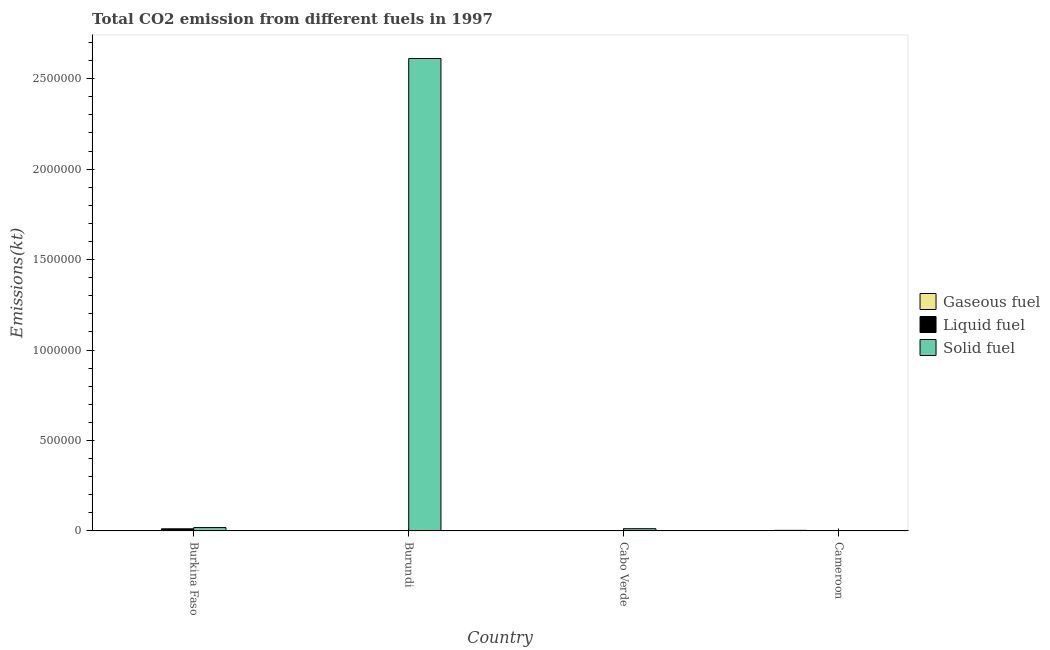How many different coloured bars are there?
Keep it short and to the point. 3. How many groups of bars are there?
Make the answer very short. 4. Are the number of bars per tick equal to the number of legend labels?
Give a very brief answer. Yes. How many bars are there on the 1st tick from the left?
Your response must be concise. 3. What is the label of the 1st group of bars from the left?
Ensure brevity in your answer.  Burkina Faso. What is the amount of co2 emissions from gaseous fuel in Burkina Faso?
Your answer should be compact. 806.74. Across all countries, what is the maximum amount of co2 emissions from liquid fuel?
Offer a very short reply. 1.17e+04. Across all countries, what is the minimum amount of co2 emissions from solid fuel?
Give a very brief answer. 861.75. In which country was the amount of co2 emissions from gaseous fuel maximum?
Offer a very short reply. Cameroon. In which country was the amount of co2 emissions from gaseous fuel minimum?
Give a very brief answer. Cabo Verde. What is the total amount of co2 emissions from liquid fuel in the graph?
Your answer should be very brief. 1.43e+04. What is the difference between the amount of co2 emissions from liquid fuel in Burkina Faso and that in Cabo Verde?
Ensure brevity in your answer.  1.14e+04. What is the difference between the amount of co2 emissions from gaseous fuel in Burundi and the amount of co2 emissions from liquid fuel in Cameroon?
Provide a succinct answer. -1162.44. What is the average amount of co2 emissions from solid fuel per country?
Ensure brevity in your answer.  6.61e+05. What is the difference between the amount of co2 emissions from gaseous fuel and amount of co2 emissions from solid fuel in Cameroon?
Make the answer very short. 2354.21. In how many countries, is the amount of co2 emissions from solid fuel greater than 1300000 kt?
Provide a short and direct response. 1. What is the ratio of the amount of co2 emissions from liquid fuel in Cabo Verde to that in Cameroon?
Provide a short and direct response. 0.2. Is the amount of co2 emissions from solid fuel in Burkina Faso less than that in Cameroon?
Your response must be concise. No. Is the difference between the amount of co2 emissions from liquid fuel in Cabo Verde and Cameroon greater than the difference between the amount of co2 emissions from solid fuel in Cabo Verde and Cameroon?
Offer a terse response. No. What is the difference between the highest and the second highest amount of co2 emissions from liquid fuel?
Your answer should be very brief. 1.03e+04. What is the difference between the highest and the lowest amount of co2 emissions from liquid fuel?
Your response must be concise. 1.14e+04. What does the 3rd bar from the left in Burundi represents?
Provide a succinct answer. Solid fuel. What does the 3rd bar from the right in Burundi represents?
Provide a succinct answer. Gaseous fuel. Is it the case that in every country, the sum of the amount of co2 emissions from gaseous fuel and amount of co2 emissions from liquid fuel is greater than the amount of co2 emissions from solid fuel?
Keep it short and to the point. No. Are all the bars in the graph horizontal?
Offer a terse response. No. How many countries are there in the graph?
Offer a terse response. 4. What is the difference between two consecutive major ticks on the Y-axis?
Keep it short and to the point. 5.00e+05. Does the graph contain grids?
Give a very brief answer. No. Where does the legend appear in the graph?
Give a very brief answer. Center right. How are the legend labels stacked?
Give a very brief answer. Vertical. What is the title of the graph?
Make the answer very short. Total CO2 emission from different fuels in 1997. What is the label or title of the X-axis?
Provide a succinct answer. Country. What is the label or title of the Y-axis?
Offer a very short reply. Emissions(kt). What is the Emissions(kt) in Gaseous fuel in Burkina Faso?
Your answer should be very brief. 806.74. What is the Emissions(kt) in Liquid fuel in Burkina Faso?
Your response must be concise. 1.17e+04. What is the Emissions(kt) of Solid fuel in Burkina Faso?
Offer a terse response. 1.86e+04. What is the Emissions(kt) of Gaseous fuel in Burundi?
Your answer should be compact. 304.36. What is the Emissions(kt) in Liquid fuel in Burundi?
Offer a very short reply. 788.4. What is the Emissions(kt) of Solid fuel in Burundi?
Give a very brief answer. 2.61e+06. What is the Emissions(kt) in Gaseous fuel in Cabo Verde?
Give a very brief answer. 143.01. What is the Emissions(kt) in Liquid fuel in Cabo Verde?
Give a very brief answer. 289.69. What is the Emissions(kt) in Solid fuel in Cabo Verde?
Your answer should be very brief. 1.23e+04. What is the Emissions(kt) in Gaseous fuel in Cameroon?
Provide a succinct answer. 3215.96. What is the Emissions(kt) of Liquid fuel in Cameroon?
Your answer should be compact. 1466.8. What is the Emissions(kt) in Solid fuel in Cameroon?
Provide a short and direct response. 861.75. Across all countries, what is the maximum Emissions(kt) in Gaseous fuel?
Provide a short and direct response. 3215.96. Across all countries, what is the maximum Emissions(kt) of Liquid fuel?
Give a very brief answer. 1.17e+04. Across all countries, what is the maximum Emissions(kt) in Solid fuel?
Offer a very short reply. 2.61e+06. Across all countries, what is the minimum Emissions(kt) in Gaseous fuel?
Your answer should be very brief. 143.01. Across all countries, what is the minimum Emissions(kt) of Liquid fuel?
Your answer should be compact. 289.69. Across all countries, what is the minimum Emissions(kt) of Solid fuel?
Provide a short and direct response. 861.75. What is the total Emissions(kt) of Gaseous fuel in the graph?
Offer a very short reply. 4470.07. What is the total Emissions(kt) in Liquid fuel in the graph?
Your answer should be compact. 1.43e+04. What is the total Emissions(kt) in Solid fuel in the graph?
Provide a succinct answer. 2.64e+06. What is the difference between the Emissions(kt) in Gaseous fuel in Burkina Faso and that in Burundi?
Keep it short and to the point. 502.38. What is the difference between the Emissions(kt) of Liquid fuel in Burkina Faso and that in Burundi?
Offer a very short reply. 1.09e+04. What is the difference between the Emissions(kt) in Solid fuel in Burkina Faso and that in Burundi?
Give a very brief answer. -2.59e+06. What is the difference between the Emissions(kt) of Gaseous fuel in Burkina Faso and that in Cabo Verde?
Provide a succinct answer. 663.73. What is the difference between the Emissions(kt) in Liquid fuel in Burkina Faso and that in Cabo Verde?
Keep it short and to the point. 1.14e+04. What is the difference between the Emissions(kt) in Solid fuel in Burkina Faso and that in Cabo Verde?
Offer a very short reply. 6321.91. What is the difference between the Emissions(kt) of Gaseous fuel in Burkina Faso and that in Cameroon?
Your answer should be very brief. -2409.22. What is the difference between the Emissions(kt) of Liquid fuel in Burkina Faso and that in Cameroon?
Your answer should be compact. 1.03e+04. What is the difference between the Emissions(kt) in Solid fuel in Burkina Faso and that in Cameroon?
Offer a very short reply. 1.78e+04. What is the difference between the Emissions(kt) in Gaseous fuel in Burundi and that in Cabo Verde?
Your answer should be very brief. 161.35. What is the difference between the Emissions(kt) of Liquid fuel in Burundi and that in Cabo Verde?
Make the answer very short. 498.71. What is the difference between the Emissions(kt) of Solid fuel in Burundi and that in Cabo Verde?
Your response must be concise. 2.60e+06. What is the difference between the Emissions(kt) of Gaseous fuel in Burundi and that in Cameroon?
Provide a short and direct response. -2911.6. What is the difference between the Emissions(kt) in Liquid fuel in Burundi and that in Cameroon?
Ensure brevity in your answer.  -678.39. What is the difference between the Emissions(kt) of Solid fuel in Burundi and that in Cameroon?
Keep it short and to the point. 2.61e+06. What is the difference between the Emissions(kt) in Gaseous fuel in Cabo Verde and that in Cameroon?
Provide a succinct answer. -3072.95. What is the difference between the Emissions(kt) in Liquid fuel in Cabo Verde and that in Cameroon?
Your answer should be compact. -1177.11. What is the difference between the Emissions(kt) in Solid fuel in Cabo Verde and that in Cameroon?
Provide a succinct answer. 1.14e+04. What is the difference between the Emissions(kt) of Gaseous fuel in Burkina Faso and the Emissions(kt) of Liquid fuel in Burundi?
Your answer should be compact. 18.34. What is the difference between the Emissions(kt) in Gaseous fuel in Burkina Faso and the Emissions(kt) in Solid fuel in Burundi?
Your response must be concise. -2.61e+06. What is the difference between the Emissions(kt) in Liquid fuel in Burkina Faso and the Emissions(kt) in Solid fuel in Burundi?
Keep it short and to the point. -2.60e+06. What is the difference between the Emissions(kt) in Gaseous fuel in Burkina Faso and the Emissions(kt) in Liquid fuel in Cabo Verde?
Your answer should be compact. 517.05. What is the difference between the Emissions(kt) in Gaseous fuel in Burkina Faso and the Emissions(kt) in Solid fuel in Cabo Verde?
Provide a short and direct response. -1.15e+04. What is the difference between the Emissions(kt) in Liquid fuel in Burkina Faso and the Emissions(kt) in Solid fuel in Cabo Verde?
Offer a terse response. -572.05. What is the difference between the Emissions(kt) in Gaseous fuel in Burkina Faso and the Emissions(kt) in Liquid fuel in Cameroon?
Make the answer very short. -660.06. What is the difference between the Emissions(kt) of Gaseous fuel in Burkina Faso and the Emissions(kt) of Solid fuel in Cameroon?
Keep it short and to the point. -55.01. What is the difference between the Emissions(kt) in Liquid fuel in Burkina Faso and the Emissions(kt) in Solid fuel in Cameroon?
Give a very brief answer. 1.09e+04. What is the difference between the Emissions(kt) in Gaseous fuel in Burundi and the Emissions(kt) in Liquid fuel in Cabo Verde?
Your answer should be very brief. 14.67. What is the difference between the Emissions(kt) of Gaseous fuel in Burundi and the Emissions(kt) of Solid fuel in Cabo Verde?
Ensure brevity in your answer.  -1.20e+04. What is the difference between the Emissions(kt) in Liquid fuel in Burundi and the Emissions(kt) in Solid fuel in Cabo Verde?
Ensure brevity in your answer.  -1.15e+04. What is the difference between the Emissions(kt) of Gaseous fuel in Burundi and the Emissions(kt) of Liquid fuel in Cameroon?
Offer a terse response. -1162.44. What is the difference between the Emissions(kt) in Gaseous fuel in Burundi and the Emissions(kt) in Solid fuel in Cameroon?
Give a very brief answer. -557.38. What is the difference between the Emissions(kt) of Liquid fuel in Burundi and the Emissions(kt) of Solid fuel in Cameroon?
Keep it short and to the point. -73.34. What is the difference between the Emissions(kt) of Gaseous fuel in Cabo Verde and the Emissions(kt) of Liquid fuel in Cameroon?
Provide a succinct answer. -1323.79. What is the difference between the Emissions(kt) in Gaseous fuel in Cabo Verde and the Emissions(kt) in Solid fuel in Cameroon?
Provide a succinct answer. -718.73. What is the difference between the Emissions(kt) in Liquid fuel in Cabo Verde and the Emissions(kt) in Solid fuel in Cameroon?
Your response must be concise. -572.05. What is the average Emissions(kt) of Gaseous fuel per country?
Provide a short and direct response. 1117.52. What is the average Emissions(kt) of Liquid fuel per country?
Your answer should be very brief. 3567.99. What is the average Emissions(kt) in Solid fuel per country?
Your answer should be compact. 6.61e+05. What is the difference between the Emissions(kt) in Gaseous fuel and Emissions(kt) in Liquid fuel in Burkina Faso?
Keep it short and to the point. -1.09e+04. What is the difference between the Emissions(kt) in Gaseous fuel and Emissions(kt) in Solid fuel in Burkina Faso?
Ensure brevity in your answer.  -1.78e+04. What is the difference between the Emissions(kt) in Liquid fuel and Emissions(kt) in Solid fuel in Burkina Faso?
Give a very brief answer. -6893.96. What is the difference between the Emissions(kt) of Gaseous fuel and Emissions(kt) of Liquid fuel in Burundi?
Offer a very short reply. -484.04. What is the difference between the Emissions(kt) in Gaseous fuel and Emissions(kt) in Solid fuel in Burundi?
Your response must be concise. -2.61e+06. What is the difference between the Emissions(kt) in Liquid fuel and Emissions(kt) in Solid fuel in Burundi?
Ensure brevity in your answer.  -2.61e+06. What is the difference between the Emissions(kt) of Gaseous fuel and Emissions(kt) of Liquid fuel in Cabo Verde?
Offer a very short reply. -146.68. What is the difference between the Emissions(kt) in Gaseous fuel and Emissions(kt) in Solid fuel in Cabo Verde?
Keep it short and to the point. -1.22e+04. What is the difference between the Emissions(kt) in Liquid fuel and Emissions(kt) in Solid fuel in Cabo Verde?
Provide a short and direct response. -1.20e+04. What is the difference between the Emissions(kt) of Gaseous fuel and Emissions(kt) of Liquid fuel in Cameroon?
Ensure brevity in your answer.  1749.16. What is the difference between the Emissions(kt) of Gaseous fuel and Emissions(kt) of Solid fuel in Cameroon?
Provide a succinct answer. 2354.21. What is the difference between the Emissions(kt) in Liquid fuel and Emissions(kt) in Solid fuel in Cameroon?
Provide a short and direct response. 605.05. What is the ratio of the Emissions(kt) of Gaseous fuel in Burkina Faso to that in Burundi?
Offer a terse response. 2.65. What is the ratio of the Emissions(kt) of Liquid fuel in Burkina Faso to that in Burundi?
Provide a succinct answer. 14.87. What is the ratio of the Emissions(kt) in Solid fuel in Burkina Faso to that in Burundi?
Provide a succinct answer. 0.01. What is the ratio of the Emissions(kt) in Gaseous fuel in Burkina Faso to that in Cabo Verde?
Provide a short and direct response. 5.64. What is the ratio of the Emissions(kt) in Liquid fuel in Burkina Faso to that in Cabo Verde?
Your answer should be compact. 40.48. What is the ratio of the Emissions(kt) of Solid fuel in Burkina Faso to that in Cabo Verde?
Your response must be concise. 1.51. What is the ratio of the Emissions(kt) in Gaseous fuel in Burkina Faso to that in Cameroon?
Ensure brevity in your answer.  0.25. What is the ratio of the Emissions(kt) of Liquid fuel in Burkina Faso to that in Cameroon?
Keep it short and to the point. 8. What is the ratio of the Emissions(kt) of Solid fuel in Burkina Faso to that in Cameroon?
Your answer should be compact. 21.61. What is the ratio of the Emissions(kt) of Gaseous fuel in Burundi to that in Cabo Verde?
Your response must be concise. 2.13. What is the ratio of the Emissions(kt) in Liquid fuel in Burundi to that in Cabo Verde?
Provide a short and direct response. 2.72. What is the ratio of the Emissions(kt) of Solid fuel in Burundi to that in Cabo Verde?
Offer a terse response. 212.35. What is the ratio of the Emissions(kt) in Gaseous fuel in Burundi to that in Cameroon?
Offer a very short reply. 0.09. What is the ratio of the Emissions(kt) of Liquid fuel in Burundi to that in Cameroon?
Your answer should be compact. 0.54. What is the ratio of the Emissions(kt) in Solid fuel in Burundi to that in Cameroon?
Offer a terse response. 3030.7. What is the ratio of the Emissions(kt) of Gaseous fuel in Cabo Verde to that in Cameroon?
Provide a short and direct response. 0.04. What is the ratio of the Emissions(kt) of Liquid fuel in Cabo Verde to that in Cameroon?
Provide a succinct answer. 0.2. What is the ratio of the Emissions(kt) of Solid fuel in Cabo Verde to that in Cameroon?
Provide a short and direct response. 14.27. What is the difference between the highest and the second highest Emissions(kt) of Gaseous fuel?
Provide a short and direct response. 2409.22. What is the difference between the highest and the second highest Emissions(kt) of Liquid fuel?
Your answer should be compact. 1.03e+04. What is the difference between the highest and the second highest Emissions(kt) in Solid fuel?
Offer a very short reply. 2.59e+06. What is the difference between the highest and the lowest Emissions(kt) in Gaseous fuel?
Give a very brief answer. 3072.95. What is the difference between the highest and the lowest Emissions(kt) in Liquid fuel?
Your answer should be very brief. 1.14e+04. What is the difference between the highest and the lowest Emissions(kt) in Solid fuel?
Provide a short and direct response. 2.61e+06. 